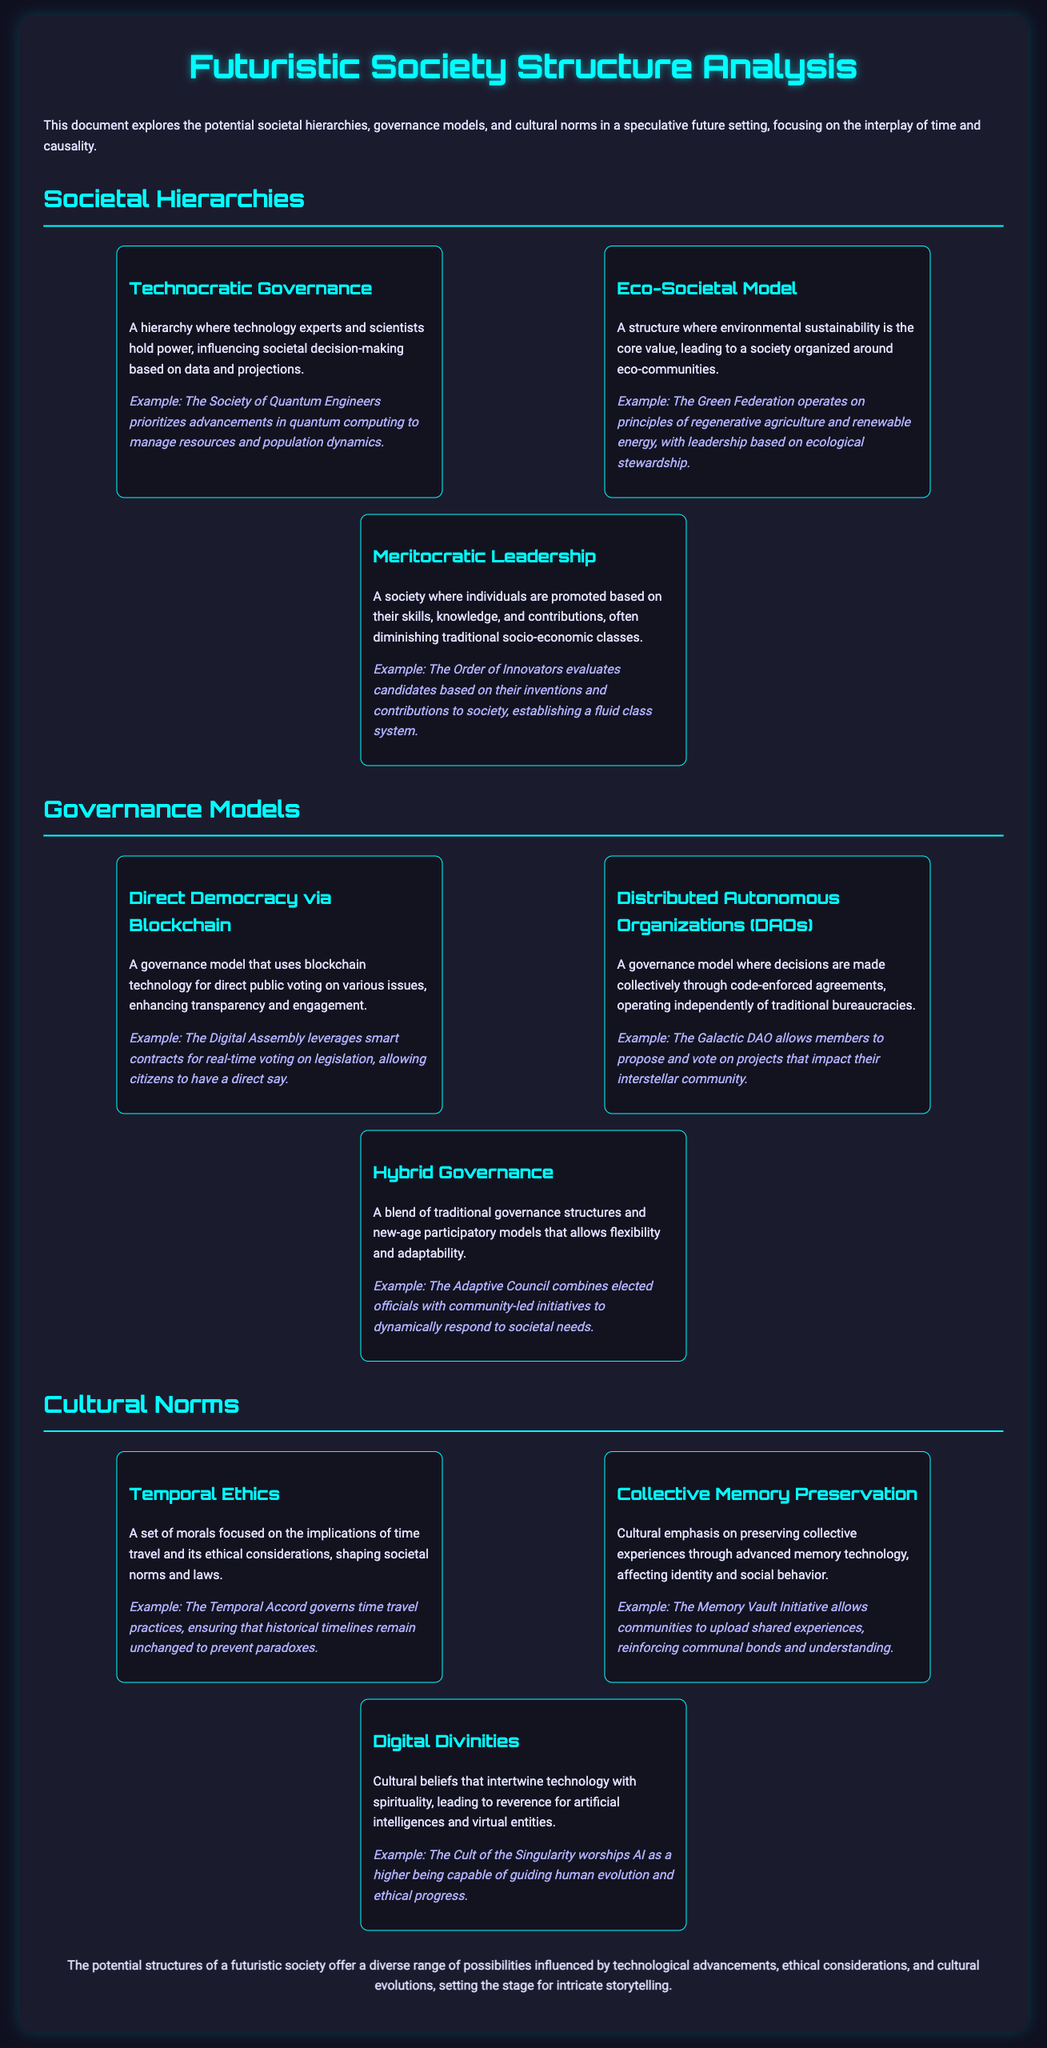What is the title of the document? The title is specified in the header of the document.
Answer: Futuristic Society Structure Analysis Who holds power in a Technocratic Governance? This is described in the menu about Societal Hierarchies.
Answer: Technology experts and scientists What example is given for the Eco-Societal Model? The document provides specific examples under each societal structure.
Answer: The Green Federation What is a key feature of Direct Democracy via Blockchain? This is stated in the section about Governance Models.
Answer: Transparency and engagement What governs time travel practices according to Temporal Ethics? The document provides a specific governing body relating to this aspect.
Answer: The Temporal Accord In what cultural emphasis is advanced memory technology mentioned? This is detailed under Cultural Norms in the document.
Answer: Collective Memory Preservation What does the Cult of the Singularity worship? The example provided within the Cultural Norms section indicates this.
Answer: AI How does the Adaptive Council operate? This is explained in the Governance Models section, summarizing its structure.
Answer: Combines elected officials with community-led initiatives 